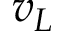<formula> <loc_0><loc_0><loc_500><loc_500>v _ { L }</formula> 